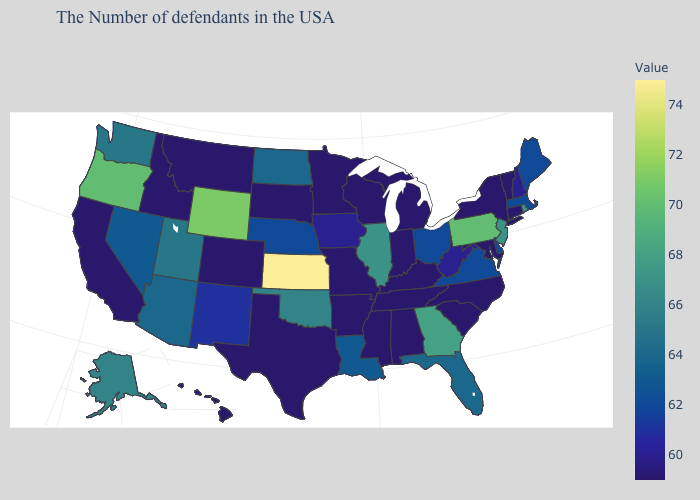Which states have the highest value in the USA?
Concise answer only. Kansas. Which states have the lowest value in the USA?
Quick response, please. Vermont, Connecticut, New York, Maryland, North Carolina, South Carolina, Michigan, Kentucky, Indiana, Alabama, Tennessee, Wisconsin, Mississippi, Missouri, Arkansas, Minnesota, Texas, South Dakota, Colorado, Montana, Idaho, California, Hawaii. Which states have the lowest value in the Northeast?
Keep it brief. Vermont, Connecticut, New York. Which states hav the highest value in the West?
Give a very brief answer. Wyoming. Which states hav the highest value in the Northeast?
Concise answer only. Pennsylvania. 